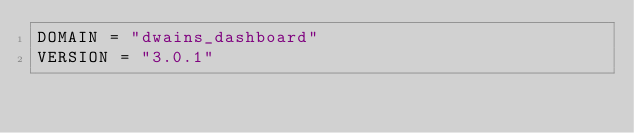Convert code to text. <code><loc_0><loc_0><loc_500><loc_500><_Python_>DOMAIN = "dwains_dashboard"
VERSION = "3.0.1"
</code> 